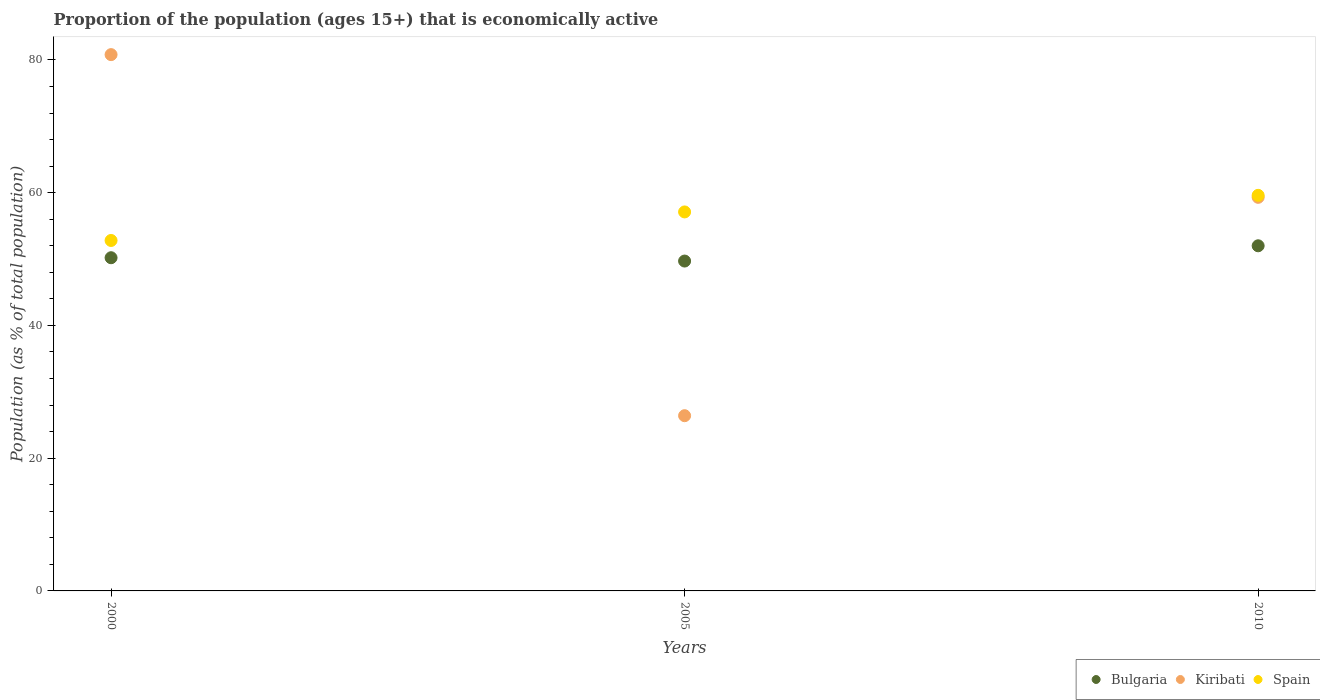What is the proportion of the population that is economically active in Kiribati in 2010?
Offer a very short reply. 59.3. Across all years, what is the maximum proportion of the population that is economically active in Kiribati?
Ensure brevity in your answer.  80.8. Across all years, what is the minimum proportion of the population that is economically active in Bulgaria?
Ensure brevity in your answer.  49.7. In which year was the proportion of the population that is economically active in Spain maximum?
Offer a very short reply. 2010. What is the total proportion of the population that is economically active in Spain in the graph?
Offer a very short reply. 169.5. What is the difference between the proportion of the population that is economically active in Bulgaria in 2000 and that in 2005?
Your answer should be compact. 0.5. What is the difference between the proportion of the population that is economically active in Bulgaria in 2000 and the proportion of the population that is economically active in Spain in 2010?
Make the answer very short. -9.4. What is the average proportion of the population that is economically active in Spain per year?
Keep it short and to the point. 56.5. In the year 2010, what is the difference between the proportion of the population that is economically active in Kiribati and proportion of the population that is economically active in Bulgaria?
Offer a very short reply. 7.3. In how many years, is the proportion of the population that is economically active in Spain greater than 76 %?
Your answer should be very brief. 0. What is the ratio of the proportion of the population that is economically active in Bulgaria in 2000 to that in 2005?
Ensure brevity in your answer.  1.01. What is the difference between the highest and the second highest proportion of the population that is economically active in Bulgaria?
Provide a short and direct response. 1.8. What is the difference between the highest and the lowest proportion of the population that is economically active in Spain?
Provide a succinct answer. 6.8. Does the proportion of the population that is economically active in Bulgaria monotonically increase over the years?
Your answer should be very brief. No. Is the proportion of the population that is economically active in Spain strictly greater than the proportion of the population that is economically active in Bulgaria over the years?
Keep it short and to the point. Yes. Is the proportion of the population that is economically active in Kiribati strictly less than the proportion of the population that is economically active in Spain over the years?
Keep it short and to the point. No. How many dotlines are there?
Your answer should be compact. 3. How many years are there in the graph?
Make the answer very short. 3. What is the difference between two consecutive major ticks on the Y-axis?
Your answer should be very brief. 20. Are the values on the major ticks of Y-axis written in scientific E-notation?
Offer a terse response. No. Does the graph contain any zero values?
Provide a short and direct response. No. Where does the legend appear in the graph?
Provide a succinct answer. Bottom right. How are the legend labels stacked?
Ensure brevity in your answer.  Horizontal. What is the title of the graph?
Your response must be concise. Proportion of the population (ages 15+) that is economically active. Does "Sint Maarten (Dutch part)" appear as one of the legend labels in the graph?
Give a very brief answer. No. What is the label or title of the X-axis?
Offer a very short reply. Years. What is the label or title of the Y-axis?
Your response must be concise. Population (as % of total population). What is the Population (as % of total population) of Bulgaria in 2000?
Your answer should be very brief. 50.2. What is the Population (as % of total population) in Kiribati in 2000?
Your answer should be compact. 80.8. What is the Population (as % of total population) of Spain in 2000?
Make the answer very short. 52.8. What is the Population (as % of total population) of Bulgaria in 2005?
Offer a very short reply. 49.7. What is the Population (as % of total population) in Kiribati in 2005?
Provide a succinct answer. 26.4. What is the Population (as % of total population) in Spain in 2005?
Offer a terse response. 57.1. What is the Population (as % of total population) of Kiribati in 2010?
Your response must be concise. 59.3. What is the Population (as % of total population) of Spain in 2010?
Provide a short and direct response. 59.6. Across all years, what is the maximum Population (as % of total population) of Kiribati?
Your response must be concise. 80.8. Across all years, what is the maximum Population (as % of total population) in Spain?
Make the answer very short. 59.6. Across all years, what is the minimum Population (as % of total population) of Bulgaria?
Your answer should be very brief. 49.7. Across all years, what is the minimum Population (as % of total population) of Kiribati?
Your response must be concise. 26.4. Across all years, what is the minimum Population (as % of total population) of Spain?
Offer a very short reply. 52.8. What is the total Population (as % of total population) of Bulgaria in the graph?
Make the answer very short. 151.9. What is the total Population (as % of total population) of Kiribati in the graph?
Provide a short and direct response. 166.5. What is the total Population (as % of total population) of Spain in the graph?
Offer a terse response. 169.5. What is the difference between the Population (as % of total population) of Bulgaria in 2000 and that in 2005?
Offer a terse response. 0.5. What is the difference between the Population (as % of total population) of Kiribati in 2000 and that in 2005?
Your response must be concise. 54.4. What is the difference between the Population (as % of total population) in Kiribati in 2000 and that in 2010?
Your response must be concise. 21.5. What is the difference between the Population (as % of total population) in Kiribati in 2005 and that in 2010?
Provide a succinct answer. -32.9. What is the difference between the Population (as % of total population) in Spain in 2005 and that in 2010?
Keep it short and to the point. -2.5. What is the difference between the Population (as % of total population) in Bulgaria in 2000 and the Population (as % of total population) in Kiribati in 2005?
Your response must be concise. 23.8. What is the difference between the Population (as % of total population) in Kiribati in 2000 and the Population (as % of total population) in Spain in 2005?
Ensure brevity in your answer.  23.7. What is the difference between the Population (as % of total population) in Bulgaria in 2000 and the Population (as % of total population) in Kiribati in 2010?
Keep it short and to the point. -9.1. What is the difference between the Population (as % of total population) in Bulgaria in 2000 and the Population (as % of total population) in Spain in 2010?
Provide a short and direct response. -9.4. What is the difference between the Population (as % of total population) in Kiribati in 2000 and the Population (as % of total population) in Spain in 2010?
Your answer should be compact. 21.2. What is the difference between the Population (as % of total population) of Bulgaria in 2005 and the Population (as % of total population) of Spain in 2010?
Ensure brevity in your answer.  -9.9. What is the difference between the Population (as % of total population) in Kiribati in 2005 and the Population (as % of total population) in Spain in 2010?
Your answer should be very brief. -33.2. What is the average Population (as % of total population) of Bulgaria per year?
Your response must be concise. 50.63. What is the average Population (as % of total population) of Kiribati per year?
Offer a terse response. 55.5. What is the average Population (as % of total population) of Spain per year?
Offer a very short reply. 56.5. In the year 2000, what is the difference between the Population (as % of total population) in Bulgaria and Population (as % of total population) in Kiribati?
Offer a terse response. -30.6. In the year 2000, what is the difference between the Population (as % of total population) in Bulgaria and Population (as % of total population) in Spain?
Ensure brevity in your answer.  -2.6. In the year 2000, what is the difference between the Population (as % of total population) in Kiribati and Population (as % of total population) in Spain?
Give a very brief answer. 28. In the year 2005, what is the difference between the Population (as % of total population) of Bulgaria and Population (as % of total population) of Kiribati?
Give a very brief answer. 23.3. In the year 2005, what is the difference between the Population (as % of total population) of Kiribati and Population (as % of total population) of Spain?
Provide a succinct answer. -30.7. In the year 2010, what is the difference between the Population (as % of total population) in Bulgaria and Population (as % of total population) in Spain?
Give a very brief answer. -7.6. In the year 2010, what is the difference between the Population (as % of total population) in Kiribati and Population (as % of total population) in Spain?
Keep it short and to the point. -0.3. What is the ratio of the Population (as % of total population) in Bulgaria in 2000 to that in 2005?
Provide a short and direct response. 1.01. What is the ratio of the Population (as % of total population) of Kiribati in 2000 to that in 2005?
Your answer should be very brief. 3.06. What is the ratio of the Population (as % of total population) in Spain in 2000 to that in 2005?
Provide a succinct answer. 0.92. What is the ratio of the Population (as % of total population) of Bulgaria in 2000 to that in 2010?
Give a very brief answer. 0.97. What is the ratio of the Population (as % of total population) of Kiribati in 2000 to that in 2010?
Your answer should be compact. 1.36. What is the ratio of the Population (as % of total population) of Spain in 2000 to that in 2010?
Keep it short and to the point. 0.89. What is the ratio of the Population (as % of total population) in Bulgaria in 2005 to that in 2010?
Ensure brevity in your answer.  0.96. What is the ratio of the Population (as % of total population) in Kiribati in 2005 to that in 2010?
Give a very brief answer. 0.45. What is the ratio of the Population (as % of total population) of Spain in 2005 to that in 2010?
Your answer should be compact. 0.96. What is the difference between the highest and the second highest Population (as % of total population) in Bulgaria?
Provide a succinct answer. 1.8. What is the difference between the highest and the second highest Population (as % of total population) in Spain?
Offer a terse response. 2.5. What is the difference between the highest and the lowest Population (as % of total population) of Kiribati?
Your answer should be very brief. 54.4. 